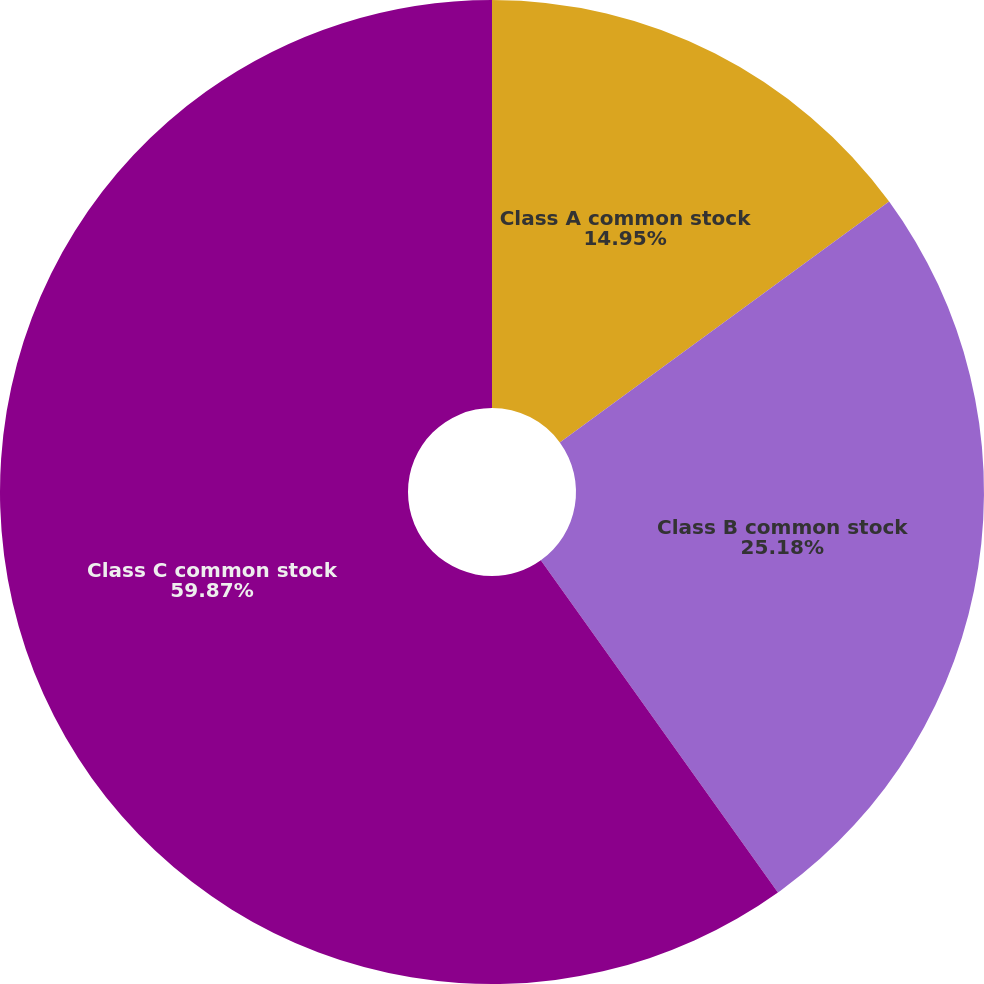Convert chart. <chart><loc_0><loc_0><loc_500><loc_500><pie_chart><fcel>Class A common stock<fcel>Class B common stock<fcel>Class C common stock<nl><fcel>14.95%<fcel>25.18%<fcel>59.87%<nl></chart> 